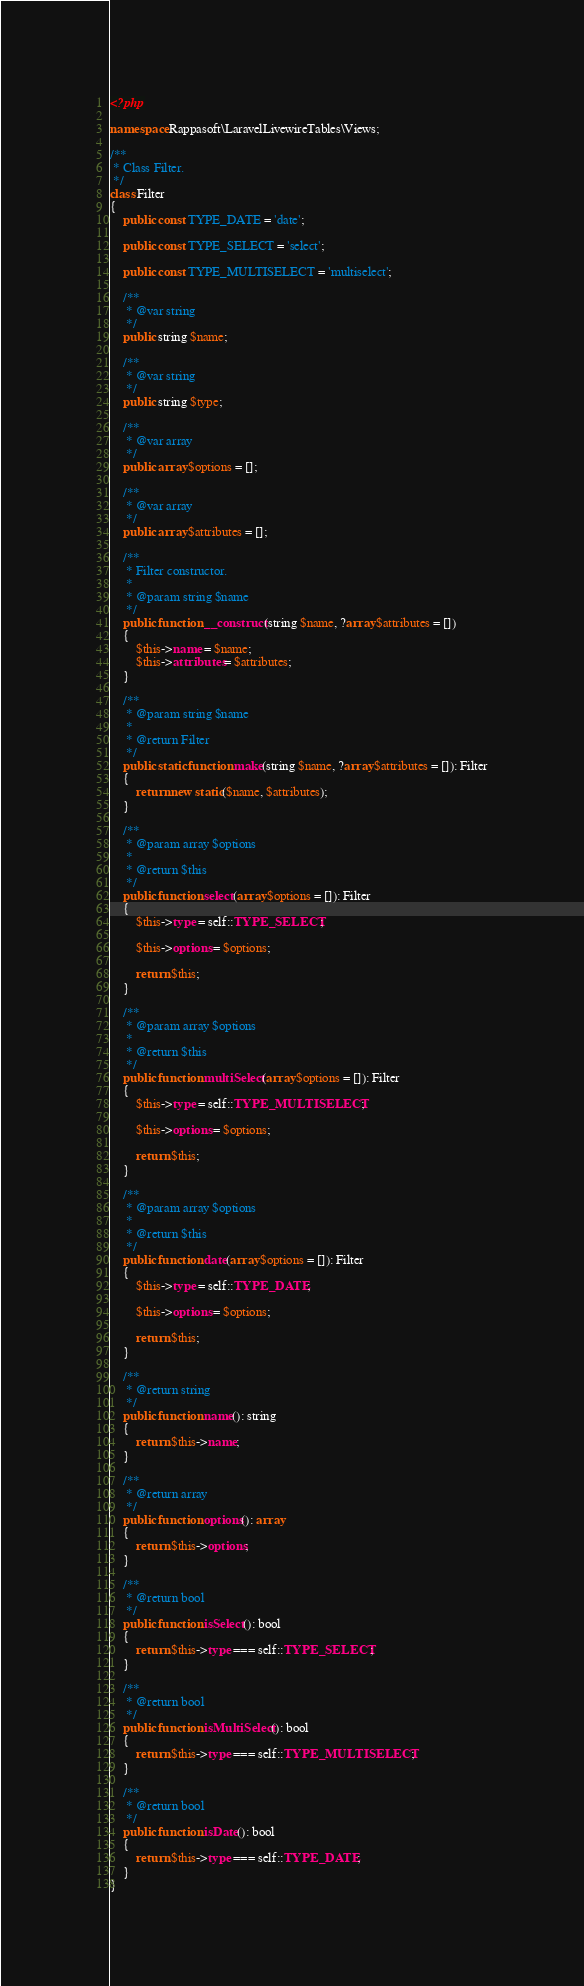Convert code to text. <code><loc_0><loc_0><loc_500><loc_500><_PHP_><?php

namespace Rappasoft\LaravelLivewireTables\Views;

/**
 * Class Filter.
 */
class Filter
{
    public const TYPE_DATE = 'date';

    public const TYPE_SELECT = 'select';

    public const TYPE_MULTISELECT = 'multiselect';

    /**
     * @var string
     */
    public string $name;

    /**
     * @var string
     */
    public string $type;

    /**
     * @var array
     */
    public array $options = [];

    /**
     * @var array
     */
    public array $attributes = [];

    /**
     * Filter constructor.
     *
     * @param string $name
     */
    public function __construct(string $name, ?array $attributes = [])
    {
        $this->name = $name;
        $this->attributes = $attributes;
    }

    /**
     * @param string $name
     *
     * @return Filter
     */
    public static function make(string $name, ?array $attributes = []): Filter
    {
        return new static($name, $attributes);
    }

    /**
     * @param array $options
     *
     * @return $this
     */
    public function select(array $options = []): Filter
    {
        $this->type = self::TYPE_SELECT;

        $this->options = $options;

        return $this;
    }

    /**
     * @param array $options
     *
     * @return $this
     */
    public function multiSelect(array $options = []): Filter
    {
        $this->type = self::TYPE_MULTISELECT;

        $this->options = $options;

        return $this;
    }

    /**
     * @param array $options
     *
     * @return $this
     */
    public function date(array $options = []): Filter
    {
        $this->type = self::TYPE_DATE;

        $this->options = $options;

        return $this;
    }

    /**
     * @return string
     */
    public function name(): string
    {
        return $this->name;
    }

    /**
     * @return array
     */
    public function options(): array
    {
        return $this->options;
    }

    /**
     * @return bool
     */
    public function isSelect(): bool
    {
        return $this->type === self::TYPE_SELECT;
    }

    /**
     * @return bool
     */
    public function isMultiSelect(): bool
    {
        return $this->type === self::TYPE_MULTISELECT;
    }

    /**
     * @return bool
     */
    public function isDate(): bool
    {
        return $this->type === self::TYPE_DATE;
    }
}
</code> 